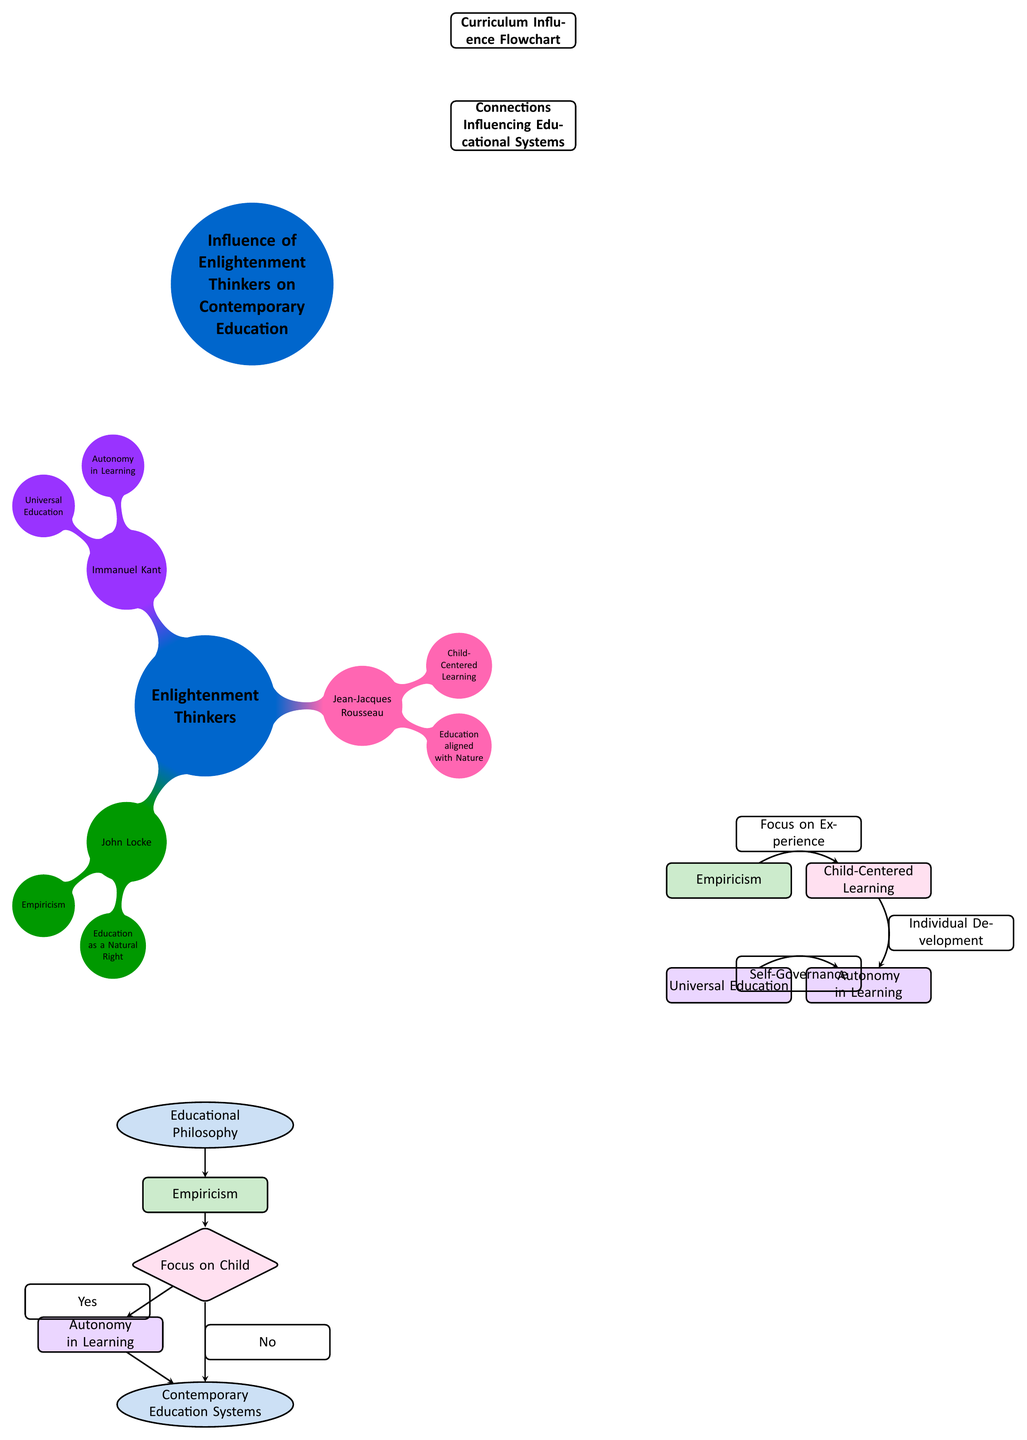What is the central concept represented in the mind map? The central concept in the mind map is "Enlightenment Thinkers," which is the main topic that the branches radiate from.
Answer: Enlightenment Thinkers How many branches stem from the central concept? There are three branches stemming from "Enlightenment Thinkers," which are John Locke, Jean-Jacques Rousseau, and Immanuel Kant.
Answer: Three What color represents Jean-Jacques Rousseau in the mind map? In the mind map, Jean-Jacques Rousseau is represented by the color pink, specifically the hue labeled as rousseaupink.
Answer: Pink What educational principle connects Empiricism and Child-Centered Learning? The edge labeled "Focus on Experience" connects Empiricism and Child-Centered Learning, indicating the relationship between these concepts.
Answer: Focus on Experience What happens if the "Focus on Child" node is answered with "No"? If the "Focus on Child" node is answered with "No," the flowchart indicates a connection to "Contemporary Education Systems," suggesting a potential lack of alignment with child-centered principles.
Answer: Contemporary Education Systems What two concepts promote learner autonomy in the curriculum influence flowchart? The concepts "Autonomy in Learning" and "Empiricism" both promote learner autonomy, highlighting differing aspects of how autonomy can be incorporated into education.
Answer: Autonomy in Learning, Empiricism Which Enlightenment thinker emphasized education as a natural right? John Locke is the Enlightenment thinker who emphasized education as a natural right, which is clearly defined in his branch of the mind map.
Answer: John Locke How many edges connect the "Focus on Child" node to other nodes in the flowchart? The "Focus on Child" node is connected to two edges; one leads to "Autonomy in Learning" and the other leads to "Contemporary Education Systems" based on the Yes and No responses.
Answer: Two What is a common theme linking John Locke, Rousseau, and Kant in their educational philosophies? A common theme linking all three thinkers is the emphasis on the individuality and rights of the learner, leading to modern educational approaches that value these concepts.
Answer: Individuality and Rights of the Learner 